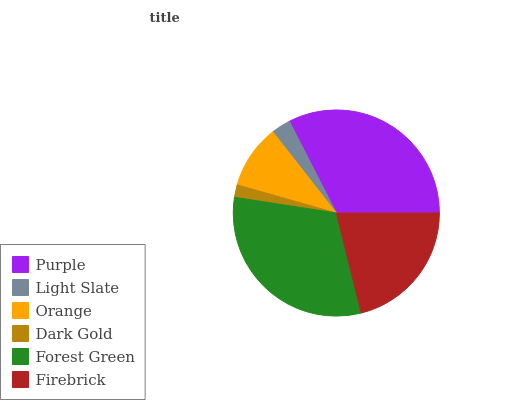Is Dark Gold the minimum?
Answer yes or no. Yes. Is Purple the maximum?
Answer yes or no. Yes. Is Light Slate the minimum?
Answer yes or no. No. Is Light Slate the maximum?
Answer yes or no. No. Is Purple greater than Light Slate?
Answer yes or no. Yes. Is Light Slate less than Purple?
Answer yes or no. Yes. Is Light Slate greater than Purple?
Answer yes or no. No. Is Purple less than Light Slate?
Answer yes or no. No. Is Firebrick the high median?
Answer yes or no. Yes. Is Orange the low median?
Answer yes or no. Yes. Is Forest Green the high median?
Answer yes or no. No. Is Firebrick the low median?
Answer yes or no. No. 